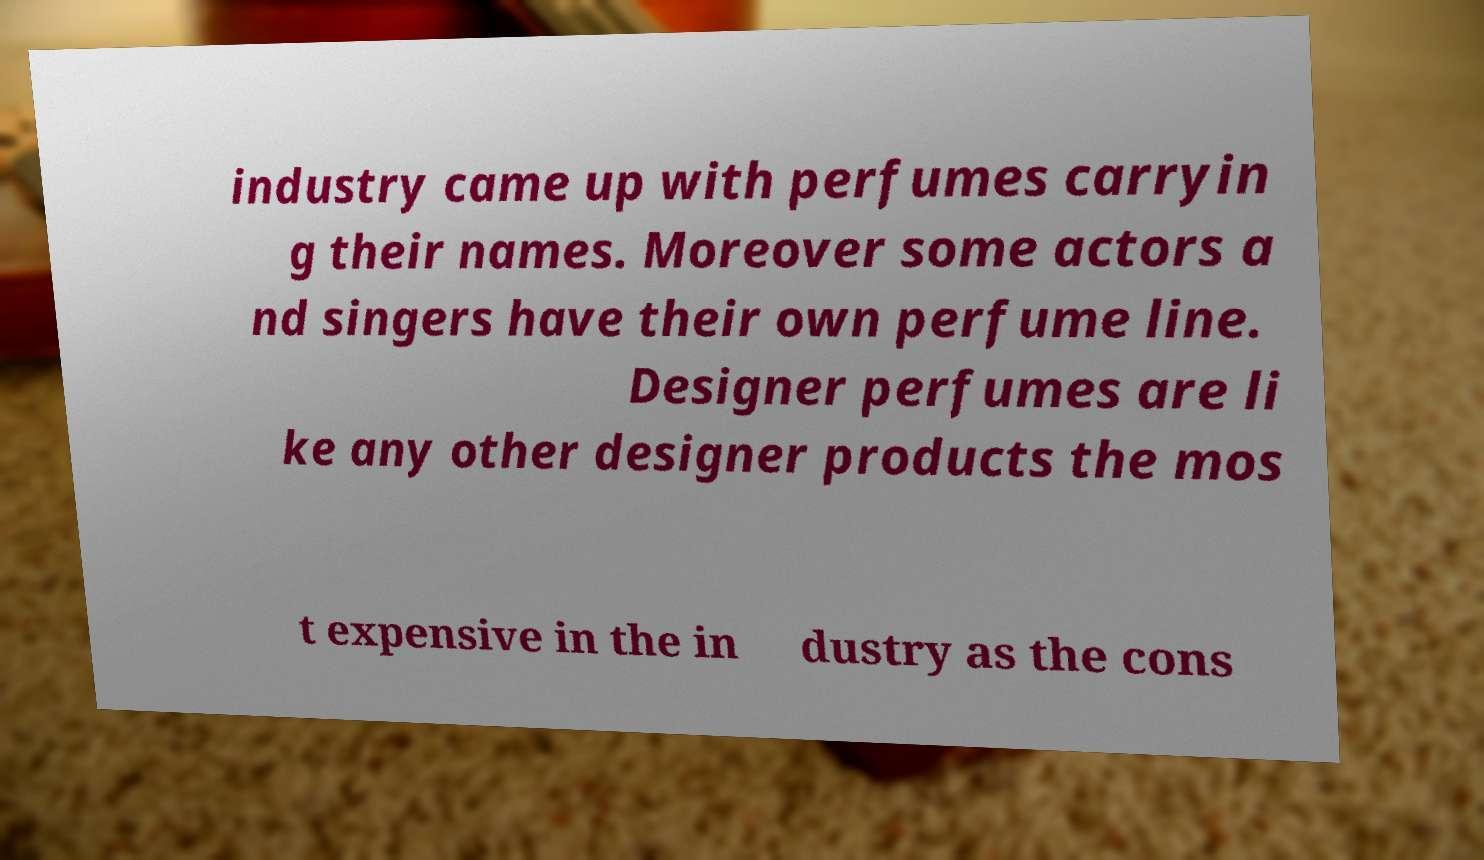For documentation purposes, I need the text within this image transcribed. Could you provide that? industry came up with perfumes carryin g their names. Moreover some actors a nd singers have their own perfume line. Designer perfumes are li ke any other designer products the mos t expensive in the in dustry as the cons 